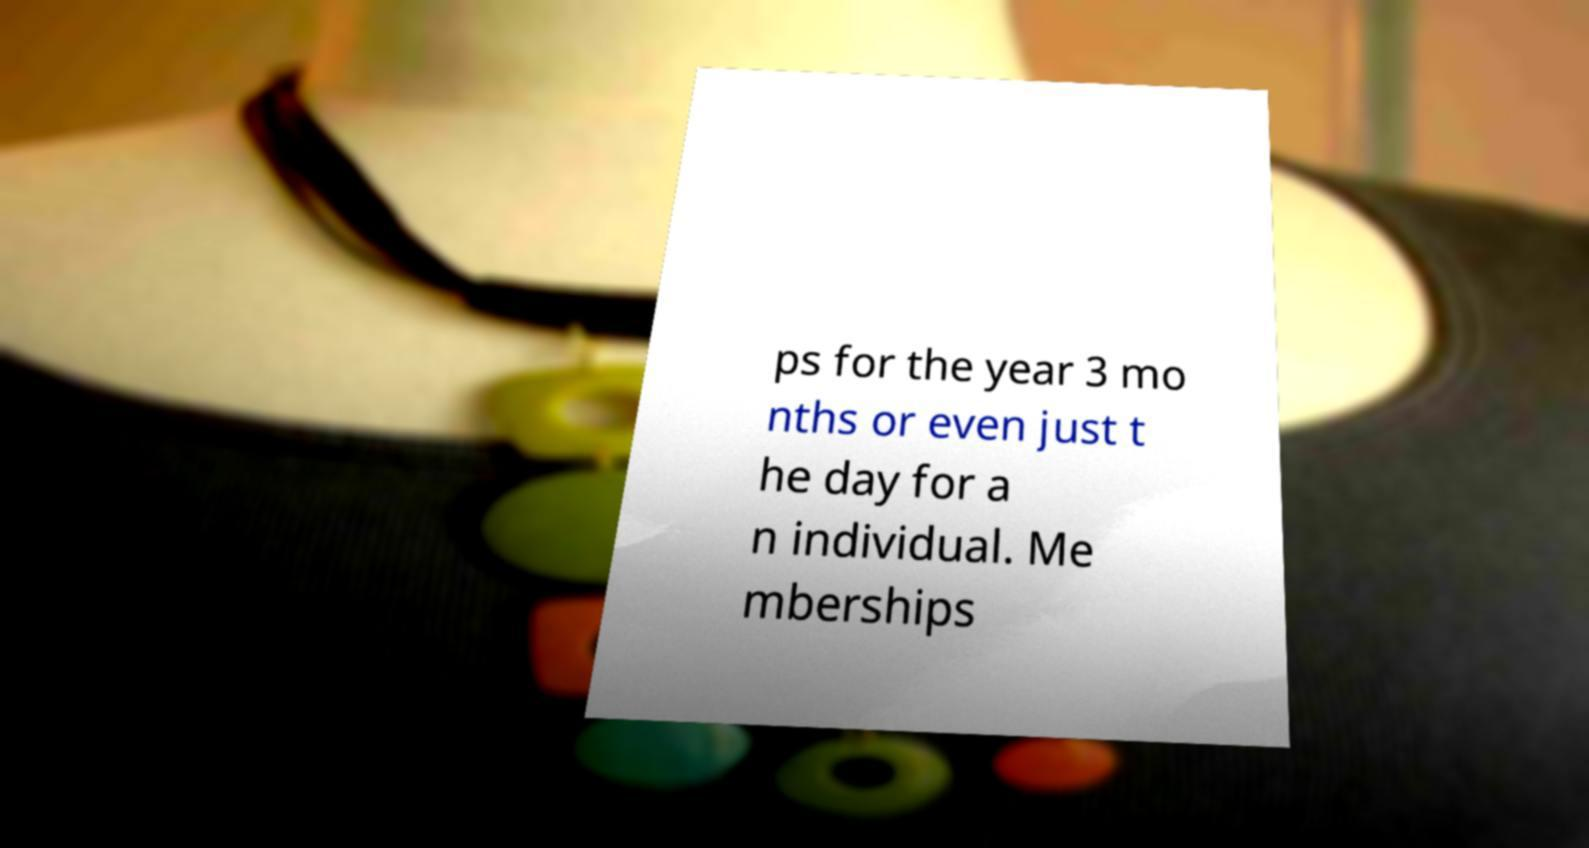What messages or text are displayed in this image? I need them in a readable, typed format. ps for the year 3 mo nths or even just t he day for a n individual. Me mberships 